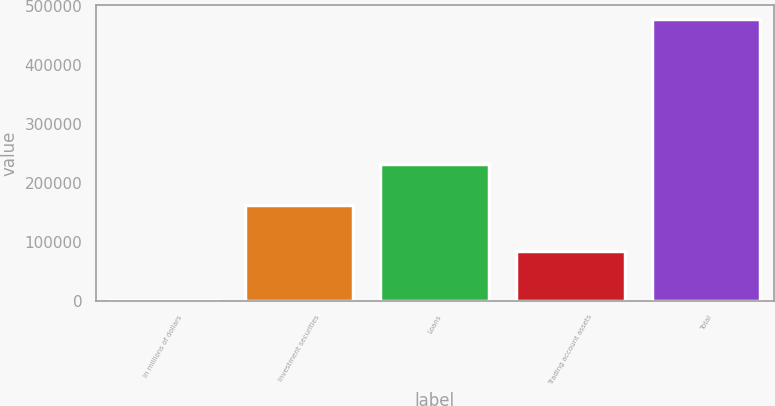Convert chart. <chart><loc_0><loc_0><loc_500><loc_500><bar_chart><fcel>In millions of dollars<fcel>Investment securities<fcel>Loans<fcel>Trading account assets<fcel>Total<nl><fcel>2016<fcel>161914<fcel>231833<fcel>84371<fcel>478118<nl></chart> 